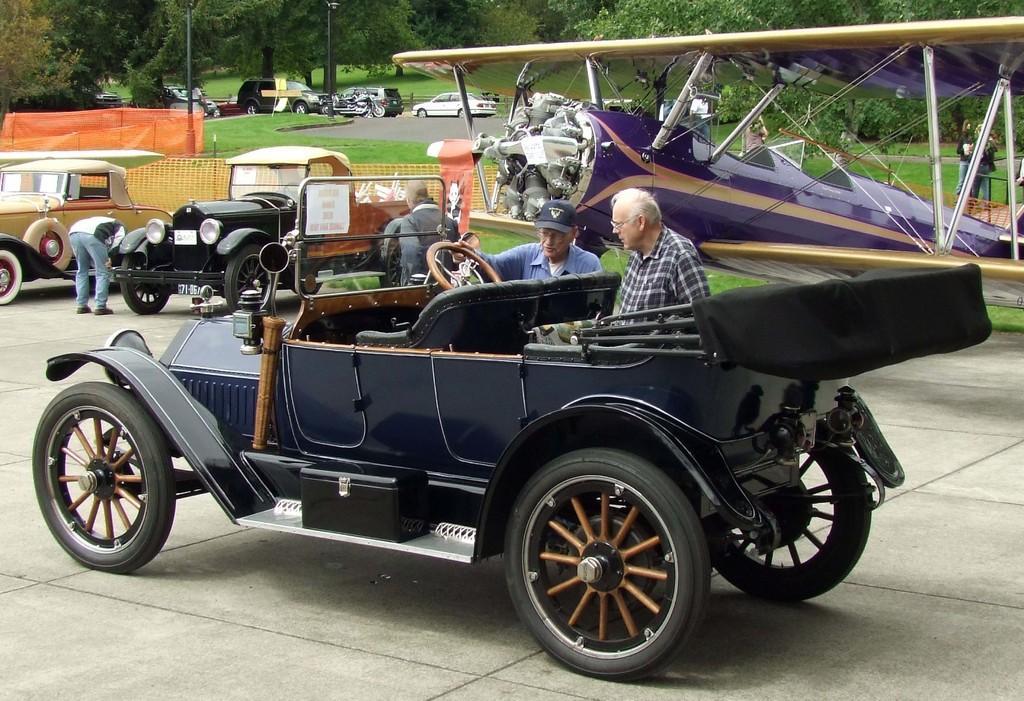In one or two sentences, can you explain what this image depicts? In this image there are cars and people were standing beside the cars. At the background there are trees and we can see grass on the surface. 